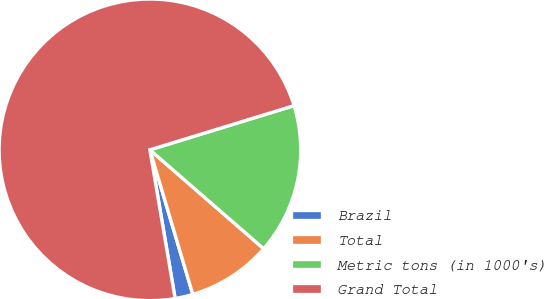<chart> <loc_0><loc_0><loc_500><loc_500><pie_chart><fcel>Brazil<fcel>Total<fcel>Metric tons (in 1000's)<fcel>Grand Total<nl><fcel>1.92%<fcel>9.02%<fcel>16.12%<fcel>72.94%<nl></chart> 